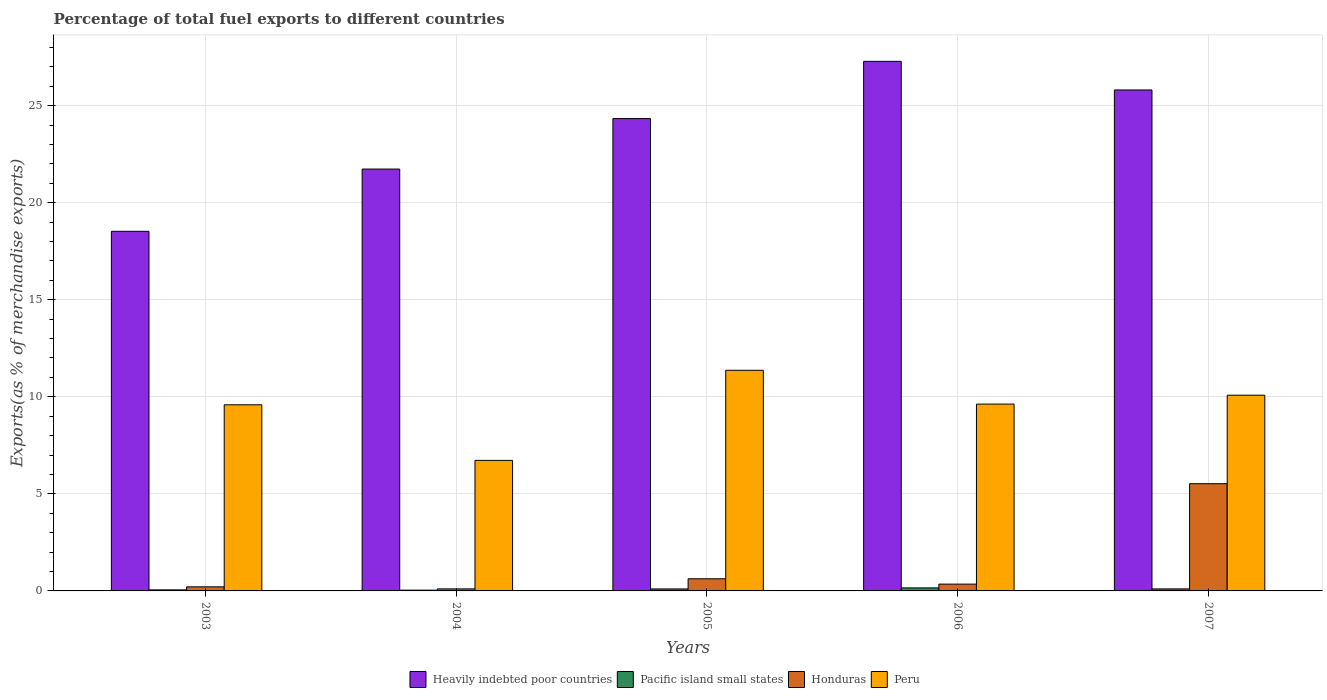How many different coloured bars are there?
Keep it short and to the point. 4. How many groups of bars are there?
Give a very brief answer. 5. Are the number of bars per tick equal to the number of legend labels?
Provide a short and direct response. Yes. Are the number of bars on each tick of the X-axis equal?
Provide a short and direct response. Yes. How many bars are there on the 4th tick from the left?
Provide a succinct answer. 4. What is the percentage of exports to different countries in Honduras in 2006?
Ensure brevity in your answer.  0.35. Across all years, what is the maximum percentage of exports to different countries in Heavily indebted poor countries?
Give a very brief answer. 27.28. Across all years, what is the minimum percentage of exports to different countries in Heavily indebted poor countries?
Give a very brief answer. 18.52. In which year was the percentage of exports to different countries in Honduras maximum?
Your answer should be compact. 2007. In which year was the percentage of exports to different countries in Peru minimum?
Keep it short and to the point. 2004. What is the total percentage of exports to different countries in Pacific island small states in the graph?
Your answer should be compact. 0.46. What is the difference between the percentage of exports to different countries in Pacific island small states in 2006 and that in 2007?
Provide a short and direct response. 0.05. What is the difference between the percentage of exports to different countries in Pacific island small states in 2003 and the percentage of exports to different countries in Peru in 2004?
Provide a short and direct response. -6.67. What is the average percentage of exports to different countries in Heavily indebted poor countries per year?
Your answer should be compact. 23.53. In the year 2005, what is the difference between the percentage of exports to different countries in Pacific island small states and percentage of exports to different countries in Peru?
Offer a very short reply. -11.26. In how many years, is the percentage of exports to different countries in Peru greater than 4 %?
Provide a short and direct response. 5. What is the ratio of the percentage of exports to different countries in Heavily indebted poor countries in 2005 to that in 2007?
Offer a terse response. 0.94. What is the difference between the highest and the second highest percentage of exports to different countries in Honduras?
Provide a succinct answer. 4.9. What is the difference between the highest and the lowest percentage of exports to different countries in Pacific island small states?
Give a very brief answer. 0.12. What does the 3rd bar from the left in 2007 represents?
Provide a short and direct response. Honduras. What does the 1st bar from the right in 2005 represents?
Offer a very short reply. Peru. Is it the case that in every year, the sum of the percentage of exports to different countries in Heavily indebted poor countries and percentage of exports to different countries in Peru is greater than the percentage of exports to different countries in Pacific island small states?
Provide a succinct answer. Yes. Does the graph contain grids?
Ensure brevity in your answer.  Yes. How many legend labels are there?
Your response must be concise. 4. How are the legend labels stacked?
Provide a succinct answer. Horizontal. What is the title of the graph?
Offer a very short reply. Percentage of total fuel exports to different countries. What is the label or title of the X-axis?
Your response must be concise. Years. What is the label or title of the Y-axis?
Give a very brief answer. Exports(as % of merchandise exports). What is the Exports(as % of merchandise exports) of Heavily indebted poor countries in 2003?
Your answer should be very brief. 18.52. What is the Exports(as % of merchandise exports) of Pacific island small states in 2003?
Make the answer very short. 0.05. What is the Exports(as % of merchandise exports) of Honduras in 2003?
Provide a succinct answer. 0.21. What is the Exports(as % of merchandise exports) in Peru in 2003?
Provide a short and direct response. 9.59. What is the Exports(as % of merchandise exports) of Heavily indebted poor countries in 2004?
Your answer should be compact. 21.73. What is the Exports(as % of merchandise exports) of Pacific island small states in 2004?
Your response must be concise. 0.04. What is the Exports(as % of merchandise exports) of Honduras in 2004?
Ensure brevity in your answer.  0.1. What is the Exports(as % of merchandise exports) of Peru in 2004?
Provide a succinct answer. 6.72. What is the Exports(as % of merchandise exports) of Heavily indebted poor countries in 2005?
Offer a very short reply. 24.33. What is the Exports(as % of merchandise exports) of Pacific island small states in 2005?
Your answer should be compact. 0.1. What is the Exports(as % of merchandise exports) of Honduras in 2005?
Make the answer very short. 0.63. What is the Exports(as % of merchandise exports) in Peru in 2005?
Offer a very short reply. 11.37. What is the Exports(as % of merchandise exports) of Heavily indebted poor countries in 2006?
Your answer should be compact. 27.28. What is the Exports(as % of merchandise exports) in Pacific island small states in 2006?
Offer a terse response. 0.16. What is the Exports(as % of merchandise exports) of Honduras in 2006?
Offer a terse response. 0.35. What is the Exports(as % of merchandise exports) in Peru in 2006?
Provide a short and direct response. 9.62. What is the Exports(as % of merchandise exports) in Heavily indebted poor countries in 2007?
Your answer should be very brief. 25.81. What is the Exports(as % of merchandise exports) in Pacific island small states in 2007?
Make the answer very short. 0.1. What is the Exports(as % of merchandise exports) of Honduras in 2007?
Ensure brevity in your answer.  5.52. What is the Exports(as % of merchandise exports) of Peru in 2007?
Your answer should be compact. 10.08. Across all years, what is the maximum Exports(as % of merchandise exports) in Heavily indebted poor countries?
Your answer should be very brief. 27.28. Across all years, what is the maximum Exports(as % of merchandise exports) in Pacific island small states?
Your response must be concise. 0.16. Across all years, what is the maximum Exports(as % of merchandise exports) of Honduras?
Offer a terse response. 5.52. Across all years, what is the maximum Exports(as % of merchandise exports) in Peru?
Your answer should be compact. 11.37. Across all years, what is the minimum Exports(as % of merchandise exports) in Heavily indebted poor countries?
Offer a terse response. 18.52. Across all years, what is the minimum Exports(as % of merchandise exports) in Pacific island small states?
Keep it short and to the point. 0.04. Across all years, what is the minimum Exports(as % of merchandise exports) of Honduras?
Your answer should be compact. 0.1. Across all years, what is the minimum Exports(as % of merchandise exports) of Peru?
Offer a very short reply. 6.72. What is the total Exports(as % of merchandise exports) of Heavily indebted poor countries in the graph?
Your answer should be very brief. 117.67. What is the total Exports(as % of merchandise exports) of Pacific island small states in the graph?
Ensure brevity in your answer.  0.46. What is the total Exports(as % of merchandise exports) of Honduras in the graph?
Offer a terse response. 6.81. What is the total Exports(as % of merchandise exports) of Peru in the graph?
Offer a terse response. 47.39. What is the difference between the Exports(as % of merchandise exports) in Heavily indebted poor countries in 2003 and that in 2004?
Offer a terse response. -3.21. What is the difference between the Exports(as % of merchandise exports) in Pacific island small states in 2003 and that in 2004?
Keep it short and to the point. 0.01. What is the difference between the Exports(as % of merchandise exports) of Honduras in 2003 and that in 2004?
Your response must be concise. 0.11. What is the difference between the Exports(as % of merchandise exports) of Peru in 2003 and that in 2004?
Give a very brief answer. 2.86. What is the difference between the Exports(as % of merchandise exports) of Heavily indebted poor countries in 2003 and that in 2005?
Your response must be concise. -5.81. What is the difference between the Exports(as % of merchandise exports) in Pacific island small states in 2003 and that in 2005?
Your response must be concise. -0.05. What is the difference between the Exports(as % of merchandise exports) in Honduras in 2003 and that in 2005?
Your answer should be compact. -0.42. What is the difference between the Exports(as % of merchandise exports) in Peru in 2003 and that in 2005?
Give a very brief answer. -1.78. What is the difference between the Exports(as % of merchandise exports) in Heavily indebted poor countries in 2003 and that in 2006?
Provide a succinct answer. -8.75. What is the difference between the Exports(as % of merchandise exports) of Pacific island small states in 2003 and that in 2006?
Make the answer very short. -0.1. What is the difference between the Exports(as % of merchandise exports) in Honduras in 2003 and that in 2006?
Ensure brevity in your answer.  -0.14. What is the difference between the Exports(as % of merchandise exports) of Peru in 2003 and that in 2006?
Your answer should be very brief. -0.04. What is the difference between the Exports(as % of merchandise exports) in Heavily indebted poor countries in 2003 and that in 2007?
Offer a terse response. -7.28. What is the difference between the Exports(as % of merchandise exports) of Pacific island small states in 2003 and that in 2007?
Your response must be concise. -0.05. What is the difference between the Exports(as % of merchandise exports) in Honduras in 2003 and that in 2007?
Ensure brevity in your answer.  -5.31. What is the difference between the Exports(as % of merchandise exports) of Peru in 2003 and that in 2007?
Make the answer very short. -0.49. What is the difference between the Exports(as % of merchandise exports) in Heavily indebted poor countries in 2004 and that in 2005?
Provide a succinct answer. -2.6. What is the difference between the Exports(as % of merchandise exports) in Pacific island small states in 2004 and that in 2005?
Ensure brevity in your answer.  -0.06. What is the difference between the Exports(as % of merchandise exports) of Honduras in 2004 and that in 2005?
Your response must be concise. -0.52. What is the difference between the Exports(as % of merchandise exports) of Peru in 2004 and that in 2005?
Keep it short and to the point. -4.64. What is the difference between the Exports(as % of merchandise exports) in Heavily indebted poor countries in 2004 and that in 2006?
Give a very brief answer. -5.55. What is the difference between the Exports(as % of merchandise exports) in Pacific island small states in 2004 and that in 2006?
Your response must be concise. -0.12. What is the difference between the Exports(as % of merchandise exports) in Honduras in 2004 and that in 2006?
Offer a terse response. -0.25. What is the difference between the Exports(as % of merchandise exports) of Peru in 2004 and that in 2006?
Your response must be concise. -2.9. What is the difference between the Exports(as % of merchandise exports) in Heavily indebted poor countries in 2004 and that in 2007?
Ensure brevity in your answer.  -4.07. What is the difference between the Exports(as % of merchandise exports) of Pacific island small states in 2004 and that in 2007?
Your answer should be compact. -0.06. What is the difference between the Exports(as % of merchandise exports) in Honduras in 2004 and that in 2007?
Your answer should be compact. -5.42. What is the difference between the Exports(as % of merchandise exports) in Peru in 2004 and that in 2007?
Provide a succinct answer. -3.36. What is the difference between the Exports(as % of merchandise exports) in Heavily indebted poor countries in 2005 and that in 2006?
Your answer should be compact. -2.95. What is the difference between the Exports(as % of merchandise exports) of Pacific island small states in 2005 and that in 2006?
Provide a short and direct response. -0.05. What is the difference between the Exports(as % of merchandise exports) of Honduras in 2005 and that in 2006?
Your answer should be very brief. 0.27. What is the difference between the Exports(as % of merchandise exports) of Peru in 2005 and that in 2006?
Offer a very short reply. 1.74. What is the difference between the Exports(as % of merchandise exports) of Heavily indebted poor countries in 2005 and that in 2007?
Provide a short and direct response. -1.47. What is the difference between the Exports(as % of merchandise exports) in Pacific island small states in 2005 and that in 2007?
Offer a terse response. -0. What is the difference between the Exports(as % of merchandise exports) in Honduras in 2005 and that in 2007?
Offer a terse response. -4.9. What is the difference between the Exports(as % of merchandise exports) in Peru in 2005 and that in 2007?
Provide a succinct answer. 1.28. What is the difference between the Exports(as % of merchandise exports) in Heavily indebted poor countries in 2006 and that in 2007?
Offer a very short reply. 1.47. What is the difference between the Exports(as % of merchandise exports) in Pacific island small states in 2006 and that in 2007?
Your answer should be compact. 0.05. What is the difference between the Exports(as % of merchandise exports) in Honduras in 2006 and that in 2007?
Make the answer very short. -5.17. What is the difference between the Exports(as % of merchandise exports) of Peru in 2006 and that in 2007?
Make the answer very short. -0.46. What is the difference between the Exports(as % of merchandise exports) in Heavily indebted poor countries in 2003 and the Exports(as % of merchandise exports) in Pacific island small states in 2004?
Your response must be concise. 18.49. What is the difference between the Exports(as % of merchandise exports) in Heavily indebted poor countries in 2003 and the Exports(as % of merchandise exports) in Honduras in 2004?
Make the answer very short. 18.42. What is the difference between the Exports(as % of merchandise exports) of Heavily indebted poor countries in 2003 and the Exports(as % of merchandise exports) of Peru in 2004?
Keep it short and to the point. 11.8. What is the difference between the Exports(as % of merchandise exports) in Pacific island small states in 2003 and the Exports(as % of merchandise exports) in Honduras in 2004?
Make the answer very short. -0.05. What is the difference between the Exports(as % of merchandise exports) in Pacific island small states in 2003 and the Exports(as % of merchandise exports) in Peru in 2004?
Offer a terse response. -6.67. What is the difference between the Exports(as % of merchandise exports) in Honduras in 2003 and the Exports(as % of merchandise exports) in Peru in 2004?
Provide a succinct answer. -6.51. What is the difference between the Exports(as % of merchandise exports) in Heavily indebted poor countries in 2003 and the Exports(as % of merchandise exports) in Pacific island small states in 2005?
Make the answer very short. 18.42. What is the difference between the Exports(as % of merchandise exports) of Heavily indebted poor countries in 2003 and the Exports(as % of merchandise exports) of Honduras in 2005?
Your response must be concise. 17.9. What is the difference between the Exports(as % of merchandise exports) of Heavily indebted poor countries in 2003 and the Exports(as % of merchandise exports) of Peru in 2005?
Provide a succinct answer. 7.16. What is the difference between the Exports(as % of merchandise exports) of Pacific island small states in 2003 and the Exports(as % of merchandise exports) of Honduras in 2005?
Keep it short and to the point. -0.57. What is the difference between the Exports(as % of merchandise exports) of Pacific island small states in 2003 and the Exports(as % of merchandise exports) of Peru in 2005?
Provide a short and direct response. -11.31. What is the difference between the Exports(as % of merchandise exports) of Honduras in 2003 and the Exports(as % of merchandise exports) of Peru in 2005?
Your answer should be very brief. -11.16. What is the difference between the Exports(as % of merchandise exports) in Heavily indebted poor countries in 2003 and the Exports(as % of merchandise exports) in Pacific island small states in 2006?
Ensure brevity in your answer.  18.37. What is the difference between the Exports(as % of merchandise exports) in Heavily indebted poor countries in 2003 and the Exports(as % of merchandise exports) in Honduras in 2006?
Your answer should be compact. 18.17. What is the difference between the Exports(as % of merchandise exports) in Heavily indebted poor countries in 2003 and the Exports(as % of merchandise exports) in Peru in 2006?
Make the answer very short. 8.9. What is the difference between the Exports(as % of merchandise exports) in Pacific island small states in 2003 and the Exports(as % of merchandise exports) in Honduras in 2006?
Provide a succinct answer. -0.3. What is the difference between the Exports(as % of merchandise exports) in Pacific island small states in 2003 and the Exports(as % of merchandise exports) in Peru in 2006?
Offer a terse response. -9.57. What is the difference between the Exports(as % of merchandise exports) of Honduras in 2003 and the Exports(as % of merchandise exports) of Peru in 2006?
Your response must be concise. -9.41. What is the difference between the Exports(as % of merchandise exports) of Heavily indebted poor countries in 2003 and the Exports(as % of merchandise exports) of Pacific island small states in 2007?
Ensure brevity in your answer.  18.42. What is the difference between the Exports(as % of merchandise exports) in Heavily indebted poor countries in 2003 and the Exports(as % of merchandise exports) in Honduras in 2007?
Give a very brief answer. 13. What is the difference between the Exports(as % of merchandise exports) in Heavily indebted poor countries in 2003 and the Exports(as % of merchandise exports) in Peru in 2007?
Keep it short and to the point. 8.44. What is the difference between the Exports(as % of merchandise exports) in Pacific island small states in 2003 and the Exports(as % of merchandise exports) in Honduras in 2007?
Offer a very short reply. -5.47. What is the difference between the Exports(as % of merchandise exports) in Pacific island small states in 2003 and the Exports(as % of merchandise exports) in Peru in 2007?
Offer a very short reply. -10.03. What is the difference between the Exports(as % of merchandise exports) in Honduras in 2003 and the Exports(as % of merchandise exports) in Peru in 2007?
Keep it short and to the point. -9.87. What is the difference between the Exports(as % of merchandise exports) of Heavily indebted poor countries in 2004 and the Exports(as % of merchandise exports) of Pacific island small states in 2005?
Offer a terse response. 21.63. What is the difference between the Exports(as % of merchandise exports) of Heavily indebted poor countries in 2004 and the Exports(as % of merchandise exports) of Honduras in 2005?
Give a very brief answer. 21.11. What is the difference between the Exports(as % of merchandise exports) in Heavily indebted poor countries in 2004 and the Exports(as % of merchandise exports) in Peru in 2005?
Make the answer very short. 10.37. What is the difference between the Exports(as % of merchandise exports) of Pacific island small states in 2004 and the Exports(as % of merchandise exports) of Honduras in 2005?
Provide a short and direct response. -0.59. What is the difference between the Exports(as % of merchandise exports) in Pacific island small states in 2004 and the Exports(as % of merchandise exports) in Peru in 2005?
Offer a very short reply. -11.33. What is the difference between the Exports(as % of merchandise exports) of Honduras in 2004 and the Exports(as % of merchandise exports) of Peru in 2005?
Your response must be concise. -11.26. What is the difference between the Exports(as % of merchandise exports) of Heavily indebted poor countries in 2004 and the Exports(as % of merchandise exports) of Pacific island small states in 2006?
Offer a very short reply. 21.57. What is the difference between the Exports(as % of merchandise exports) in Heavily indebted poor countries in 2004 and the Exports(as % of merchandise exports) in Honduras in 2006?
Give a very brief answer. 21.38. What is the difference between the Exports(as % of merchandise exports) in Heavily indebted poor countries in 2004 and the Exports(as % of merchandise exports) in Peru in 2006?
Keep it short and to the point. 12.11. What is the difference between the Exports(as % of merchandise exports) in Pacific island small states in 2004 and the Exports(as % of merchandise exports) in Honduras in 2006?
Offer a terse response. -0.31. What is the difference between the Exports(as % of merchandise exports) in Pacific island small states in 2004 and the Exports(as % of merchandise exports) in Peru in 2006?
Provide a succinct answer. -9.59. What is the difference between the Exports(as % of merchandise exports) in Honduras in 2004 and the Exports(as % of merchandise exports) in Peru in 2006?
Your response must be concise. -9.52. What is the difference between the Exports(as % of merchandise exports) of Heavily indebted poor countries in 2004 and the Exports(as % of merchandise exports) of Pacific island small states in 2007?
Offer a terse response. 21.63. What is the difference between the Exports(as % of merchandise exports) in Heavily indebted poor countries in 2004 and the Exports(as % of merchandise exports) in Honduras in 2007?
Your answer should be very brief. 16.21. What is the difference between the Exports(as % of merchandise exports) in Heavily indebted poor countries in 2004 and the Exports(as % of merchandise exports) in Peru in 2007?
Ensure brevity in your answer.  11.65. What is the difference between the Exports(as % of merchandise exports) in Pacific island small states in 2004 and the Exports(as % of merchandise exports) in Honduras in 2007?
Give a very brief answer. -5.48. What is the difference between the Exports(as % of merchandise exports) of Pacific island small states in 2004 and the Exports(as % of merchandise exports) of Peru in 2007?
Offer a terse response. -10.04. What is the difference between the Exports(as % of merchandise exports) in Honduras in 2004 and the Exports(as % of merchandise exports) in Peru in 2007?
Make the answer very short. -9.98. What is the difference between the Exports(as % of merchandise exports) of Heavily indebted poor countries in 2005 and the Exports(as % of merchandise exports) of Pacific island small states in 2006?
Your response must be concise. 24.18. What is the difference between the Exports(as % of merchandise exports) in Heavily indebted poor countries in 2005 and the Exports(as % of merchandise exports) in Honduras in 2006?
Ensure brevity in your answer.  23.98. What is the difference between the Exports(as % of merchandise exports) of Heavily indebted poor countries in 2005 and the Exports(as % of merchandise exports) of Peru in 2006?
Provide a short and direct response. 14.71. What is the difference between the Exports(as % of merchandise exports) in Pacific island small states in 2005 and the Exports(as % of merchandise exports) in Honduras in 2006?
Ensure brevity in your answer.  -0.25. What is the difference between the Exports(as % of merchandise exports) in Pacific island small states in 2005 and the Exports(as % of merchandise exports) in Peru in 2006?
Give a very brief answer. -9.52. What is the difference between the Exports(as % of merchandise exports) of Honduras in 2005 and the Exports(as % of merchandise exports) of Peru in 2006?
Offer a very short reply. -9. What is the difference between the Exports(as % of merchandise exports) of Heavily indebted poor countries in 2005 and the Exports(as % of merchandise exports) of Pacific island small states in 2007?
Your answer should be very brief. 24.23. What is the difference between the Exports(as % of merchandise exports) in Heavily indebted poor countries in 2005 and the Exports(as % of merchandise exports) in Honduras in 2007?
Keep it short and to the point. 18.81. What is the difference between the Exports(as % of merchandise exports) in Heavily indebted poor countries in 2005 and the Exports(as % of merchandise exports) in Peru in 2007?
Your response must be concise. 14.25. What is the difference between the Exports(as % of merchandise exports) in Pacific island small states in 2005 and the Exports(as % of merchandise exports) in Honduras in 2007?
Your answer should be very brief. -5.42. What is the difference between the Exports(as % of merchandise exports) in Pacific island small states in 2005 and the Exports(as % of merchandise exports) in Peru in 2007?
Your response must be concise. -9.98. What is the difference between the Exports(as % of merchandise exports) in Honduras in 2005 and the Exports(as % of merchandise exports) in Peru in 2007?
Offer a terse response. -9.46. What is the difference between the Exports(as % of merchandise exports) in Heavily indebted poor countries in 2006 and the Exports(as % of merchandise exports) in Pacific island small states in 2007?
Provide a succinct answer. 27.18. What is the difference between the Exports(as % of merchandise exports) of Heavily indebted poor countries in 2006 and the Exports(as % of merchandise exports) of Honduras in 2007?
Provide a short and direct response. 21.76. What is the difference between the Exports(as % of merchandise exports) of Heavily indebted poor countries in 2006 and the Exports(as % of merchandise exports) of Peru in 2007?
Your answer should be very brief. 17.2. What is the difference between the Exports(as % of merchandise exports) of Pacific island small states in 2006 and the Exports(as % of merchandise exports) of Honduras in 2007?
Ensure brevity in your answer.  -5.37. What is the difference between the Exports(as % of merchandise exports) of Pacific island small states in 2006 and the Exports(as % of merchandise exports) of Peru in 2007?
Provide a short and direct response. -9.93. What is the difference between the Exports(as % of merchandise exports) in Honduras in 2006 and the Exports(as % of merchandise exports) in Peru in 2007?
Keep it short and to the point. -9.73. What is the average Exports(as % of merchandise exports) of Heavily indebted poor countries per year?
Your answer should be compact. 23.53. What is the average Exports(as % of merchandise exports) of Pacific island small states per year?
Give a very brief answer. 0.09. What is the average Exports(as % of merchandise exports) in Honduras per year?
Ensure brevity in your answer.  1.36. What is the average Exports(as % of merchandise exports) in Peru per year?
Provide a succinct answer. 9.48. In the year 2003, what is the difference between the Exports(as % of merchandise exports) of Heavily indebted poor countries and Exports(as % of merchandise exports) of Pacific island small states?
Make the answer very short. 18.47. In the year 2003, what is the difference between the Exports(as % of merchandise exports) in Heavily indebted poor countries and Exports(as % of merchandise exports) in Honduras?
Your answer should be compact. 18.31. In the year 2003, what is the difference between the Exports(as % of merchandise exports) in Heavily indebted poor countries and Exports(as % of merchandise exports) in Peru?
Your response must be concise. 8.94. In the year 2003, what is the difference between the Exports(as % of merchandise exports) in Pacific island small states and Exports(as % of merchandise exports) in Honduras?
Ensure brevity in your answer.  -0.16. In the year 2003, what is the difference between the Exports(as % of merchandise exports) of Pacific island small states and Exports(as % of merchandise exports) of Peru?
Offer a very short reply. -9.53. In the year 2003, what is the difference between the Exports(as % of merchandise exports) of Honduras and Exports(as % of merchandise exports) of Peru?
Offer a very short reply. -9.38. In the year 2004, what is the difference between the Exports(as % of merchandise exports) of Heavily indebted poor countries and Exports(as % of merchandise exports) of Pacific island small states?
Make the answer very short. 21.69. In the year 2004, what is the difference between the Exports(as % of merchandise exports) of Heavily indebted poor countries and Exports(as % of merchandise exports) of Honduras?
Your response must be concise. 21.63. In the year 2004, what is the difference between the Exports(as % of merchandise exports) in Heavily indebted poor countries and Exports(as % of merchandise exports) in Peru?
Your answer should be very brief. 15.01. In the year 2004, what is the difference between the Exports(as % of merchandise exports) in Pacific island small states and Exports(as % of merchandise exports) in Honduras?
Provide a succinct answer. -0.07. In the year 2004, what is the difference between the Exports(as % of merchandise exports) of Pacific island small states and Exports(as % of merchandise exports) of Peru?
Offer a terse response. -6.68. In the year 2004, what is the difference between the Exports(as % of merchandise exports) in Honduras and Exports(as % of merchandise exports) in Peru?
Offer a terse response. -6.62. In the year 2005, what is the difference between the Exports(as % of merchandise exports) of Heavily indebted poor countries and Exports(as % of merchandise exports) of Pacific island small states?
Your response must be concise. 24.23. In the year 2005, what is the difference between the Exports(as % of merchandise exports) of Heavily indebted poor countries and Exports(as % of merchandise exports) of Honduras?
Give a very brief answer. 23.71. In the year 2005, what is the difference between the Exports(as % of merchandise exports) of Heavily indebted poor countries and Exports(as % of merchandise exports) of Peru?
Ensure brevity in your answer.  12.97. In the year 2005, what is the difference between the Exports(as % of merchandise exports) in Pacific island small states and Exports(as % of merchandise exports) in Honduras?
Keep it short and to the point. -0.52. In the year 2005, what is the difference between the Exports(as % of merchandise exports) in Pacific island small states and Exports(as % of merchandise exports) in Peru?
Provide a succinct answer. -11.26. In the year 2005, what is the difference between the Exports(as % of merchandise exports) of Honduras and Exports(as % of merchandise exports) of Peru?
Your response must be concise. -10.74. In the year 2006, what is the difference between the Exports(as % of merchandise exports) of Heavily indebted poor countries and Exports(as % of merchandise exports) of Pacific island small states?
Provide a short and direct response. 27.12. In the year 2006, what is the difference between the Exports(as % of merchandise exports) in Heavily indebted poor countries and Exports(as % of merchandise exports) in Honduras?
Provide a short and direct response. 26.93. In the year 2006, what is the difference between the Exports(as % of merchandise exports) of Heavily indebted poor countries and Exports(as % of merchandise exports) of Peru?
Provide a succinct answer. 17.65. In the year 2006, what is the difference between the Exports(as % of merchandise exports) in Pacific island small states and Exports(as % of merchandise exports) in Honduras?
Offer a very short reply. -0.19. In the year 2006, what is the difference between the Exports(as % of merchandise exports) of Pacific island small states and Exports(as % of merchandise exports) of Peru?
Provide a short and direct response. -9.47. In the year 2006, what is the difference between the Exports(as % of merchandise exports) in Honduras and Exports(as % of merchandise exports) in Peru?
Your answer should be very brief. -9.27. In the year 2007, what is the difference between the Exports(as % of merchandise exports) in Heavily indebted poor countries and Exports(as % of merchandise exports) in Pacific island small states?
Ensure brevity in your answer.  25.7. In the year 2007, what is the difference between the Exports(as % of merchandise exports) in Heavily indebted poor countries and Exports(as % of merchandise exports) in Honduras?
Provide a succinct answer. 20.28. In the year 2007, what is the difference between the Exports(as % of merchandise exports) in Heavily indebted poor countries and Exports(as % of merchandise exports) in Peru?
Provide a succinct answer. 15.72. In the year 2007, what is the difference between the Exports(as % of merchandise exports) of Pacific island small states and Exports(as % of merchandise exports) of Honduras?
Ensure brevity in your answer.  -5.42. In the year 2007, what is the difference between the Exports(as % of merchandise exports) of Pacific island small states and Exports(as % of merchandise exports) of Peru?
Your answer should be compact. -9.98. In the year 2007, what is the difference between the Exports(as % of merchandise exports) of Honduras and Exports(as % of merchandise exports) of Peru?
Keep it short and to the point. -4.56. What is the ratio of the Exports(as % of merchandise exports) in Heavily indebted poor countries in 2003 to that in 2004?
Provide a succinct answer. 0.85. What is the ratio of the Exports(as % of merchandise exports) of Pacific island small states in 2003 to that in 2004?
Offer a very short reply. 1.37. What is the ratio of the Exports(as % of merchandise exports) of Honduras in 2003 to that in 2004?
Keep it short and to the point. 2.01. What is the ratio of the Exports(as % of merchandise exports) in Peru in 2003 to that in 2004?
Make the answer very short. 1.43. What is the ratio of the Exports(as % of merchandise exports) of Heavily indebted poor countries in 2003 to that in 2005?
Offer a terse response. 0.76. What is the ratio of the Exports(as % of merchandise exports) of Pacific island small states in 2003 to that in 2005?
Your response must be concise. 0.53. What is the ratio of the Exports(as % of merchandise exports) of Honduras in 2003 to that in 2005?
Offer a terse response. 0.34. What is the ratio of the Exports(as % of merchandise exports) in Peru in 2003 to that in 2005?
Provide a succinct answer. 0.84. What is the ratio of the Exports(as % of merchandise exports) in Heavily indebted poor countries in 2003 to that in 2006?
Your answer should be compact. 0.68. What is the ratio of the Exports(as % of merchandise exports) in Pacific island small states in 2003 to that in 2006?
Your response must be concise. 0.35. What is the ratio of the Exports(as % of merchandise exports) in Honduras in 2003 to that in 2006?
Your response must be concise. 0.6. What is the ratio of the Exports(as % of merchandise exports) in Heavily indebted poor countries in 2003 to that in 2007?
Your answer should be compact. 0.72. What is the ratio of the Exports(as % of merchandise exports) of Pacific island small states in 2003 to that in 2007?
Provide a short and direct response. 0.52. What is the ratio of the Exports(as % of merchandise exports) of Honduras in 2003 to that in 2007?
Offer a very short reply. 0.04. What is the ratio of the Exports(as % of merchandise exports) of Peru in 2003 to that in 2007?
Make the answer very short. 0.95. What is the ratio of the Exports(as % of merchandise exports) in Heavily indebted poor countries in 2004 to that in 2005?
Your response must be concise. 0.89. What is the ratio of the Exports(as % of merchandise exports) of Pacific island small states in 2004 to that in 2005?
Your response must be concise. 0.39. What is the ratio of the Exports(as % of merchandise exports) of Honduras in 2004 to that in 2005?
Your answer should be very brief. 0.17. What is the ratio of the Exports(as % of merchandise exports) in Peru in 2004 to that in 2005?
Offer a terse response. 0.59. What is the ratio of the Exports(as % of merchandise exports) of Heavily indebted poor countries in 2004 to that in 2006?
Your response must be concise. 0.8. What is the ratio of the Exports(as % of merchandise exports) in Pacific island small states in 2004 to that in 2006?
Provide a succinct answer. 0.25. What is the ratio of the Exports(as % of merchandise exports) of Honduras in 2004 to that in 2006?
Ensure brevity in your answer.  0.3. What is the ratio of the Exports(as % of merchandise exports) of Peru in 2004 to that in 2006?
Ensure brevity in your answer.  0.7. What is the ratio of the Exports(as % of merchandise exports) in Heavily indebted poor countries in 2004 to that in 2007?
Provide a succinct answer. 0.84. What is the ratio of the Exports(as % of merchandise exports) of Pacific island small states in 2004 to that in 2007?
Your answer should be very brief. 0.38. What is the ratio of the Exports(as % of merchandise exports) in Honduras in 2004 to that in 2007?
Make the answer very short. 0.02. What is the ratio of the Exports(as % of merchandise exports) in Peru in 2004 to that in 2007?
Make the answer very short. 0.67. What is the ratio of the Exports(as % of merchandise exports) in Heavily indebted poor countries in 2005 to that in 2006?
Make the answer very short. 0.89. What is the ratio of the Exports(as % of merchandise exports) of Pacific island small states in 2005 to that in 2006?
Your answer should be very brief. 0.65. What is the ratio of the Exports(as % of merchandise exports) of Honduras in 2005 to that in 2006?
Ensure brevity in your answer.  1.78. What is the ratio of the Exports(as % of merchandise exports) of Peru in 2005 to that in 2006?
Your answer should be very brief. 1.18. What is the ratio of the Exports(as % of merchandise exports) of Heavily indebted poor countries in 2005 to that in 2007?
Make the answer very short. 0.94. What is the ratio of the Exports(as % of merchandise exports) of Pacific island small states in 2005 to that in 2007?
Offer a very short reply. 0.99. What is the ratio of the Exports(as % of merchandise exports) of Honduras in 2005 to that in 2007?
Provide a short and direct response. 0.11. What is the ratio of the Exports(as % of merchandise exports) of Peru in 2005 to that in 2007?
Offer a very short reply. 1.13. What is the ratio of the Exports(as % of merchandise exports) in Heavily indebted poor countries in 2006 to that in 2007?
Offer a terse response. 1.06. What is the ratio of the Exports(as % of merchandise exports) of Pacific island small states in 2006 to that in 2007?
Provide a succinct answer. 1.51. What is the ratio of the Exports(as % of merchandise exports) of Honduras in 2006 to that in 2007?
Keep it short and to the point. 0.06. What is the ratio of the Exports(as % of merchandise exports) of Peru in 2006 to that in 2007?
Offer a terse response. 0.95. What is the difference between the highest and the second highest Exports(as % of merchandise exports) in Heavily indebted poor countries?
Keep it short and to the point. 1.47. What is the difference between the highest and the second highest Exports(as % of merchandise exports) in Pacific island small states?
Provide a short and direct response. 0.05. What is the difference between the highest and the second highest Exports(as % of merchandise exports) of Honduras?
Keep it short and to the point. 4.9. What is the difference between the highest and the second highest Exports(as % of merchandise exports) of Peru?
Your answer should be compact. 1.28. What is the difference between the highest and the lowest Exports(as % of merchandise exports) of Heavily indebted poor countries?
Your answer should be very brief. 8.75. What is the difference between the highest and the lowest Exports(as % of merchandise exports) in Pacific island small states?
Provide a succinct answer. 0.12. What is the difference between the highest and the lowest Exports(as % of merchandise exports) in Honduras?
Provide a succinct answer. 5.42. What is the difference between the highest and the lowest Exports(as % of merchandise exports) in Peru?
Your answer should be compact. 4.64. 